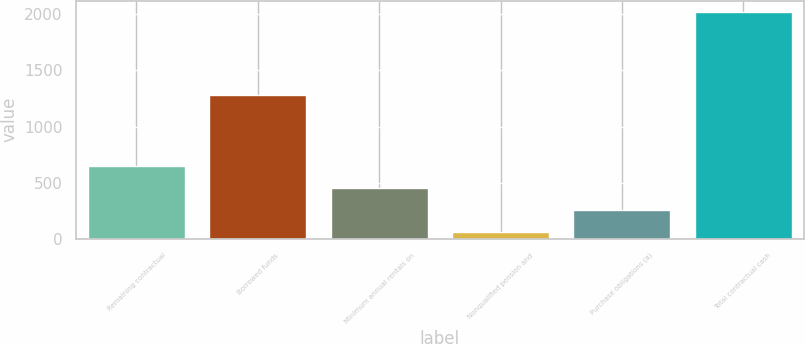<chart> <loc_0><loc_0><loc_500><loc_500><bar_chart><fcel>Remaining contractual<fcel>Borrowed funds<fcel>Minimum annual rentals on<fcel>Nonqualified pension and<fcel>Purchase obligations (a)<fcel>Total contractual cash<nl><fcel>652.2<fcel>1282<fcel>456.8<fcel>66<fcel>261.4<fcel>2020<nl></chart> 